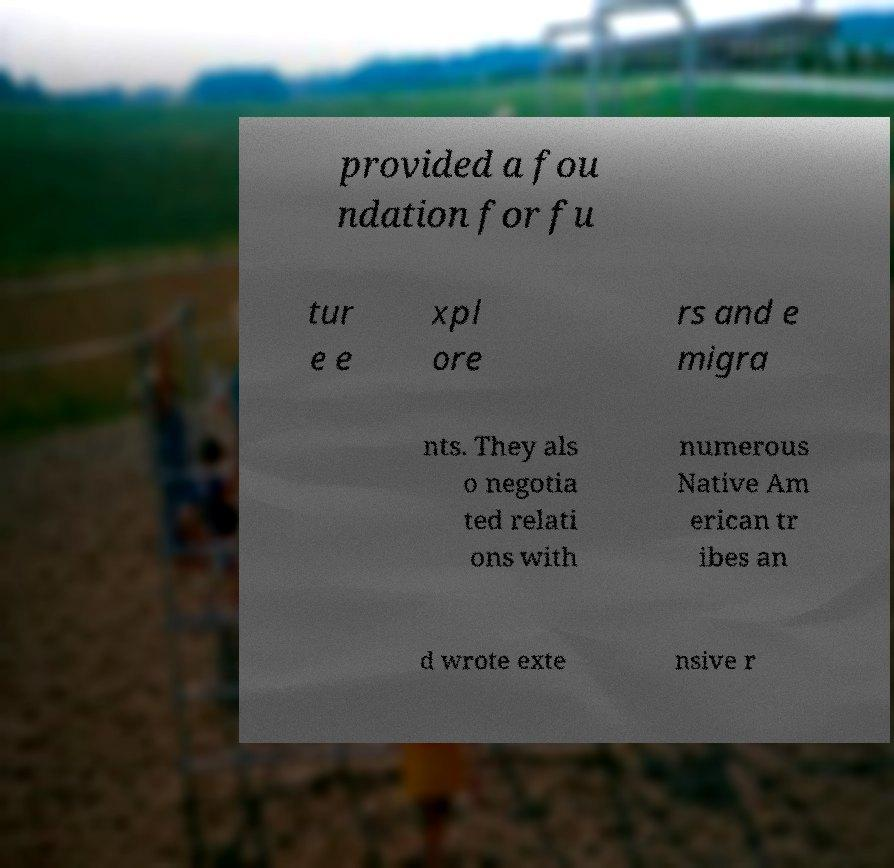Can you read and provide the text displayed in the image?This photo seems to have some interesting text. Can you extract and type it out for me? provided a fou ndation for fu tur e e xpl ore rs and e migra nts. They als o negotia ted relati ons with numerous Native Am erican tr ibes an d wrote exte nsive r 